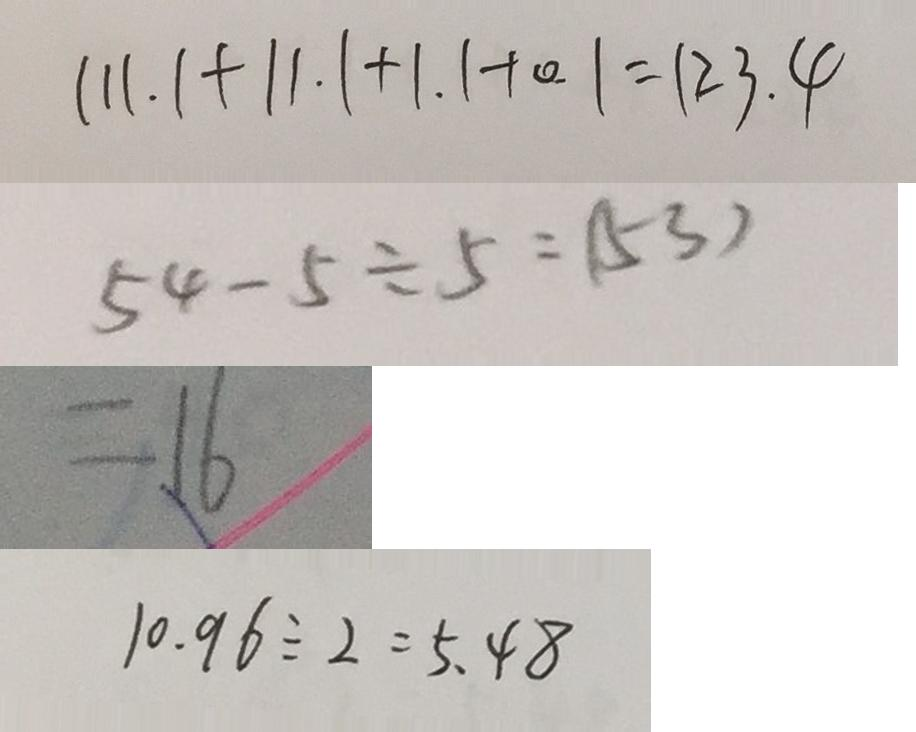<formula> <loc_0><loc_0><loc_500><loc_500>1 1 1 . 1 + 1 1 . 1 + 1 . 1 + 0 . 1 = 1 2 3 . 4 
 5 4 - 5 \div 5 = ( 5 3 ) 
 = 1 6 
 1 0 . 9 6 \div 2 = 5 . 4 8</formula> 